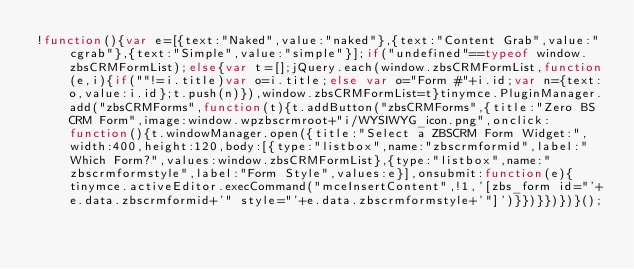<code> <loc_0><loc_0><loc_500><loc_500><_JavaScript_>!function(){var e=[{text:"Naked",value:"naked"},{text:"Content Grab",value:"cgrab"},{text:"Simple",value:"simple"}];if("undefined"==typeof window.zbsCRMFormList);else{var t=[];jQuery.each(window.zbsCRMFormList,function(e,i){if(""!=i.title)var o=i.title;else var o="Form #"+i.id;var n={text:o,value:i.id};t.push(n)}),window.zbsCRMFormList=t}tinymce.PluginManager.add("zbsCRMForms",function(t){t.addButton("zbsCRMForms",{title:"Zero BS CRM Form",image:window.wpzbscrmroot+"i/WYSIWYG_icon.png",onclick:function(){t.windowManager.open({title:"Select a ZBSCRM Form Widget:",width:400,height:120,body:[{type:"listbox",name:"zbscrmformid",label:"Which Form?",values:window.zbsCRMFormList},{type:"listbox",name:"zbscrmformstyle",label:"Form Style",values:e}],onsubmit:function(e){tinymce.activeEditor.execCommand("mceInsertContent",!1,'[zbs_form id="'+e.data.zbscrmformid+'" style="'+e.data.zbscrmformstyle+'"]')}})}})})}();</code> 